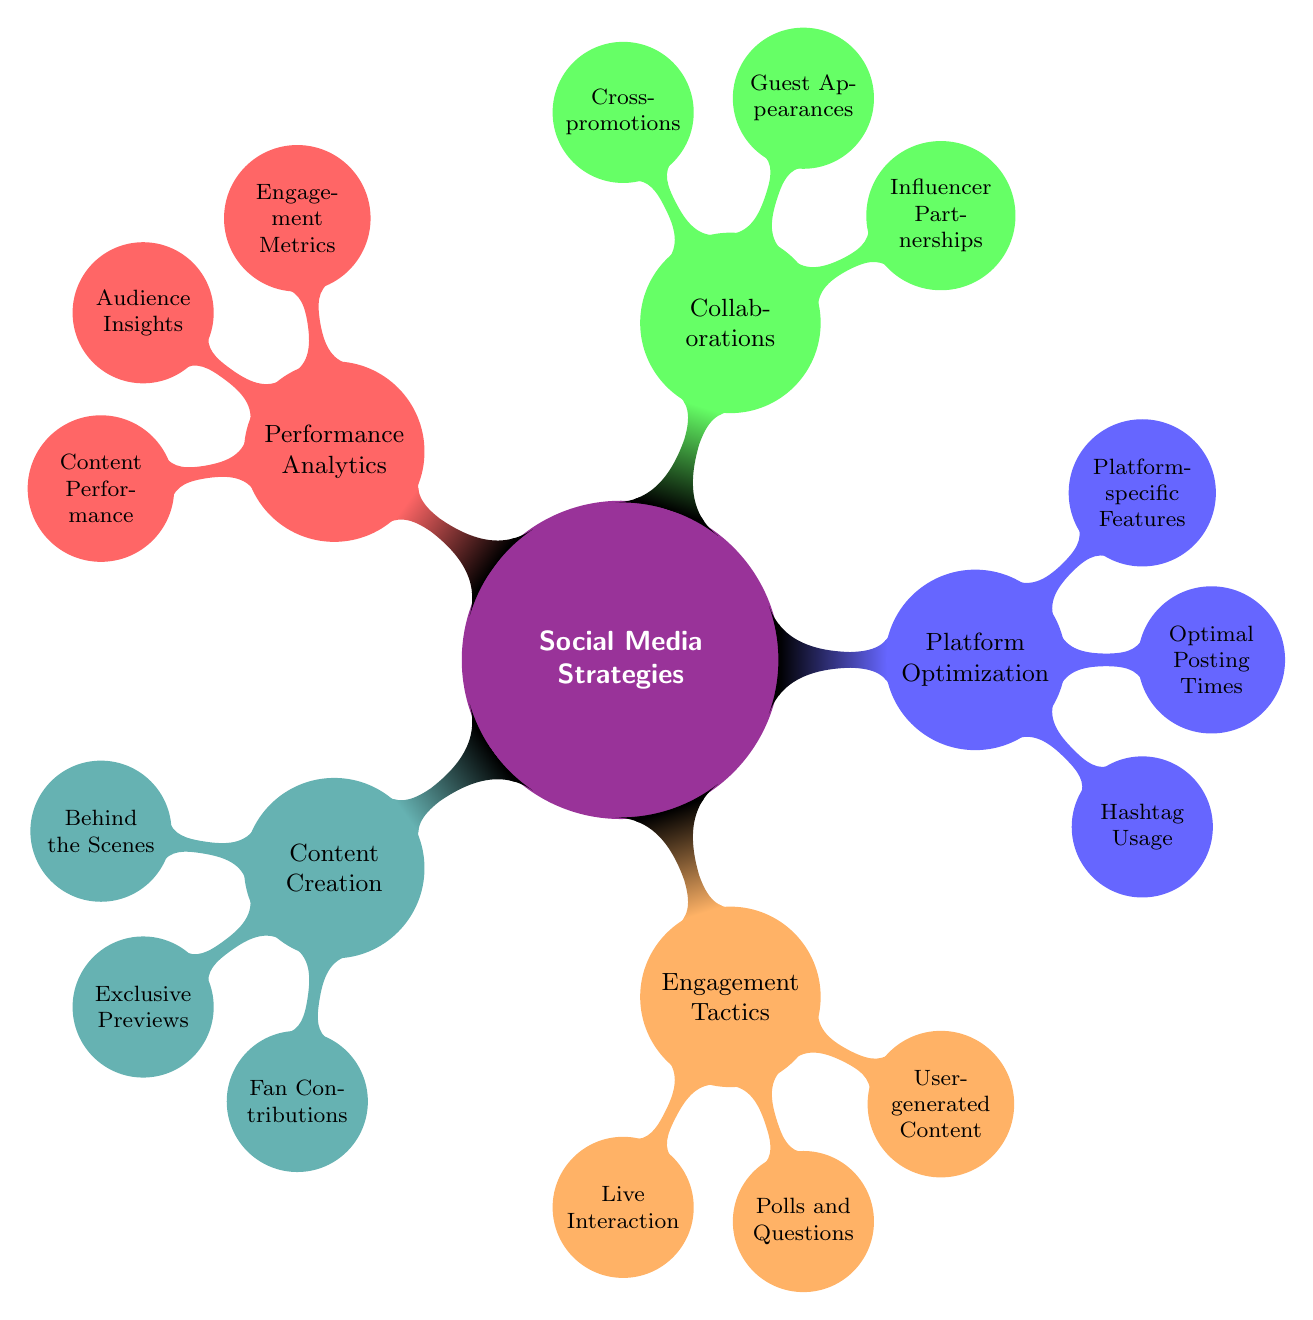What is the main topic of the mind map? The central node of the mind map is labeled "Social Media Strategies," which indicates that this is the primary subject being discussed in the diagram.
Answer: Social Media Strategies How many main branches are in the diagram? The main topic branches into five categories: Content Creation, Engagement Tactics, Platform Optimization, Collaborations, and Performance Analytics. Thus, there are five branches in total.
Answer: 5 Which branch includes "Live Interaction"? "Live Interaction" is found under the "Engagement Tactics" branch, which focuses on ways to engage with fans through live methods.
Answer: Engagement Tactics What type of partnerships are mentioned in the Collaborations branch? Within the "Collaborations" branch, "Influencer Partnerships" are listed, highlighting a method of collaboration with social media influencers.
Answer: Influencer Partnerships What are two examples of content under Content Creation? The "Content Creation" branch includes "Behind the Scenes" and "Fan Contributions," among others. These provide specific types of content an artist may create for their audience.
Answer: Behind the Scenes, Fan Contributions How does "Audience Insights" relate to "Performance Analytics"? "Audience Insights" is a part of the "Performance Analytics" branch and focuses on understanding demographic information and peak engagement times, which is essential for analyzing overall performance.
Answer: It is a sub-item of Performance Analytics Which platform feature is highlighted under Platform Optimization? "Platform-specific Features" is the highlighted element in the "Platform Optimization" branch, indicating different tools available for artists on social media platforms.
Answer: Platform-specific Features What is the relationship between "User-generated Content" and engagement? "User-generated Content" appears under "Engagement Tactics" and emphasizes the importance of fan-created material in enhancing fan engagement and community involvement.
Answer: It promotes fan engagement 